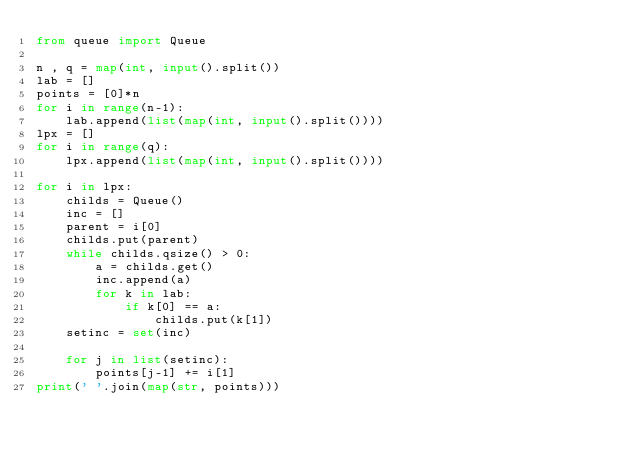<code> <loc_0><loc_0><loc_500><loc_500><_Python_>from queue import Queue

n , q = map(int, input().split())
lab = []
points = [0]*n
for i in range(n-1):
    lab.append(list(map(int, input().split())))
lpx = []
for i in range(q):
    lpx.append(list(map(int, input().split())))

for i in lpx:
    childs = Queue()
    inc = []
    parent = i[0]
    childs.put(parent)
    while childs.qsize() > 0:
        a = childs.get()
        inc.append(a)
        for k in lab:
            if k[0] == a:
                childs.put(k[1])
    setinc = set(inc)

    for j in list(setinc):
        points[j-1] += i[1]
print(' '.join(map(str, points)))</code> 